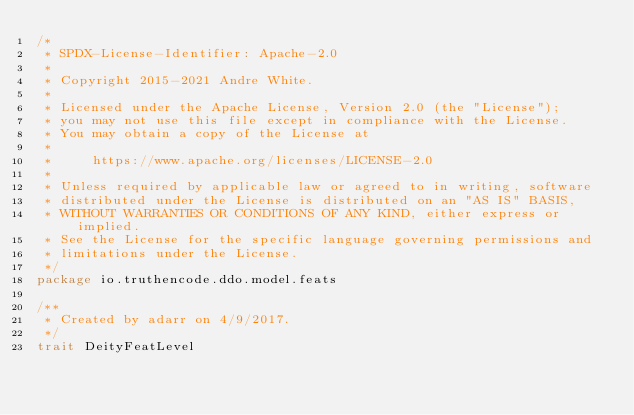<code> <loc_0><loc_0><loc_500><loc_500><_Scala_>/*
 * SPDX-License-Identifier: Apache-2.0
 *
 * Copyright 2015-2021 Andre White.
 *
 * Licensed under the Apache License, Version 2.0 (the "License");
 * you may not use this file except in compliance with the License.
 * You may obtain a copy of the License at
 *
 *     https://www.apache.org/licenses/LICENSE-2.0
 *
 * Unless required by applicable law or agreed to in writing, software
 * distributed under the License is distributed on an "AS IS" BASIS,
 * WITHOUT WARRANTIES OR CONDITIONS OF ANY KIND, either express or implied.
 * See the License for the specific language governing permissions and
 * limitations under the License.
 */
package io.truthencode.ddo.model.feats

/**
 * Created by adarr on 4/9/2017.
 */
trait DeityFeatLevel
</code> 